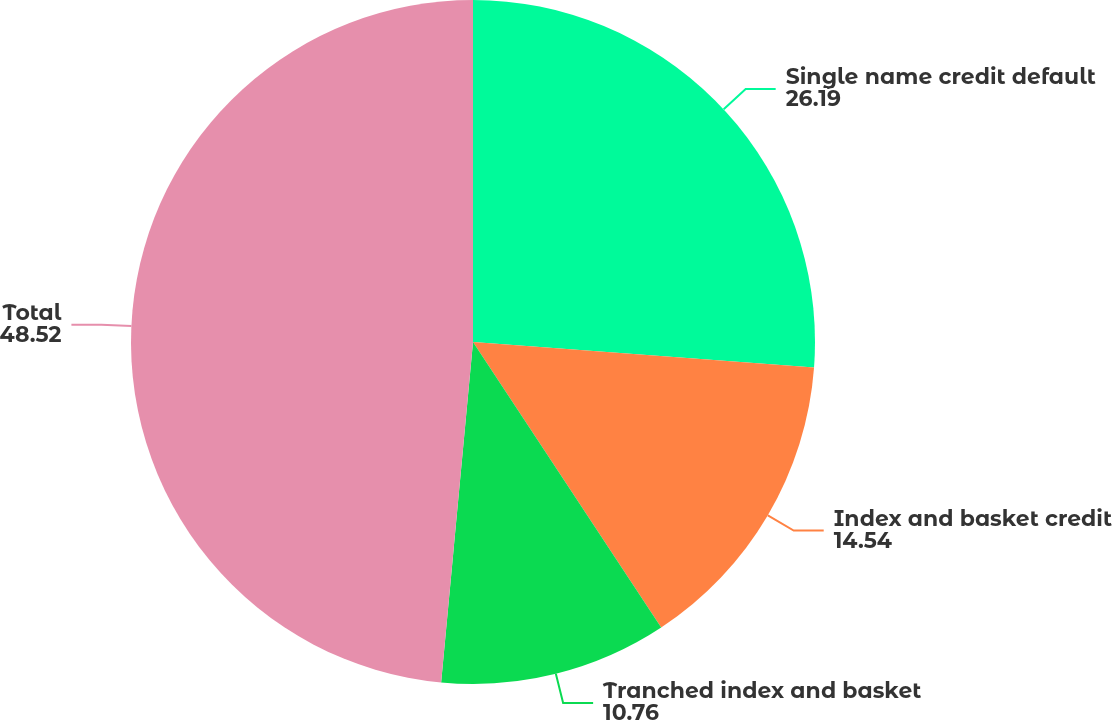Convert chart. <chart><loc_0><loc_0><loc_500><loc_500><pie_chart><fcel>Single name credit default<fcel>Index and basket credit<fcel>Tranched index and basket<fcel>Total<nl><fcel>26.19%<fcel>14.54%<fcel>10.76%<fcel>48.52%<nl></chart> 